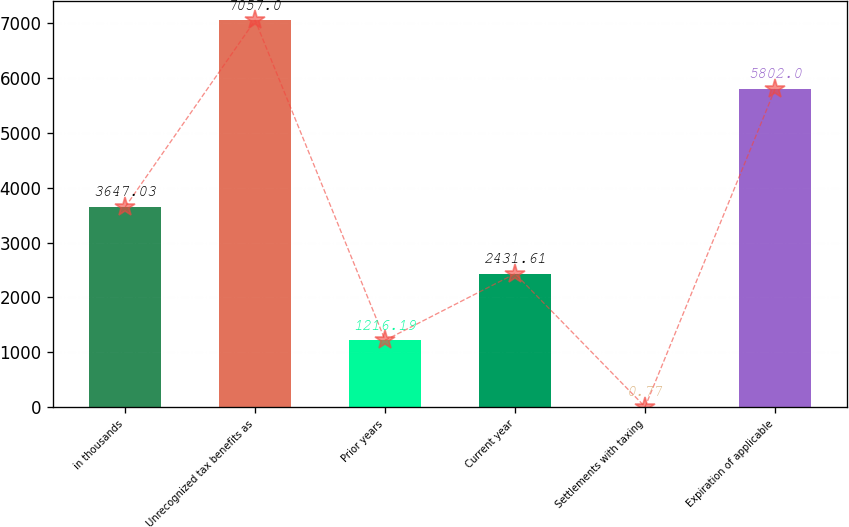Convert chart. <chart><loc_0><loc_0><loc_500><loc_500><bar_chart><fcel>in thousands<fcel>Unrecognized tax benefits as<fcel>Prior years<fcel>Current year<fcel>Settlements with taxing<fcel>Expiration of applicable<nl><fcel>3647.03<fcel>7057<fcel>1216.19<fcel>2431.61<fcel>0.77<fcel>5802<nl></chart> 